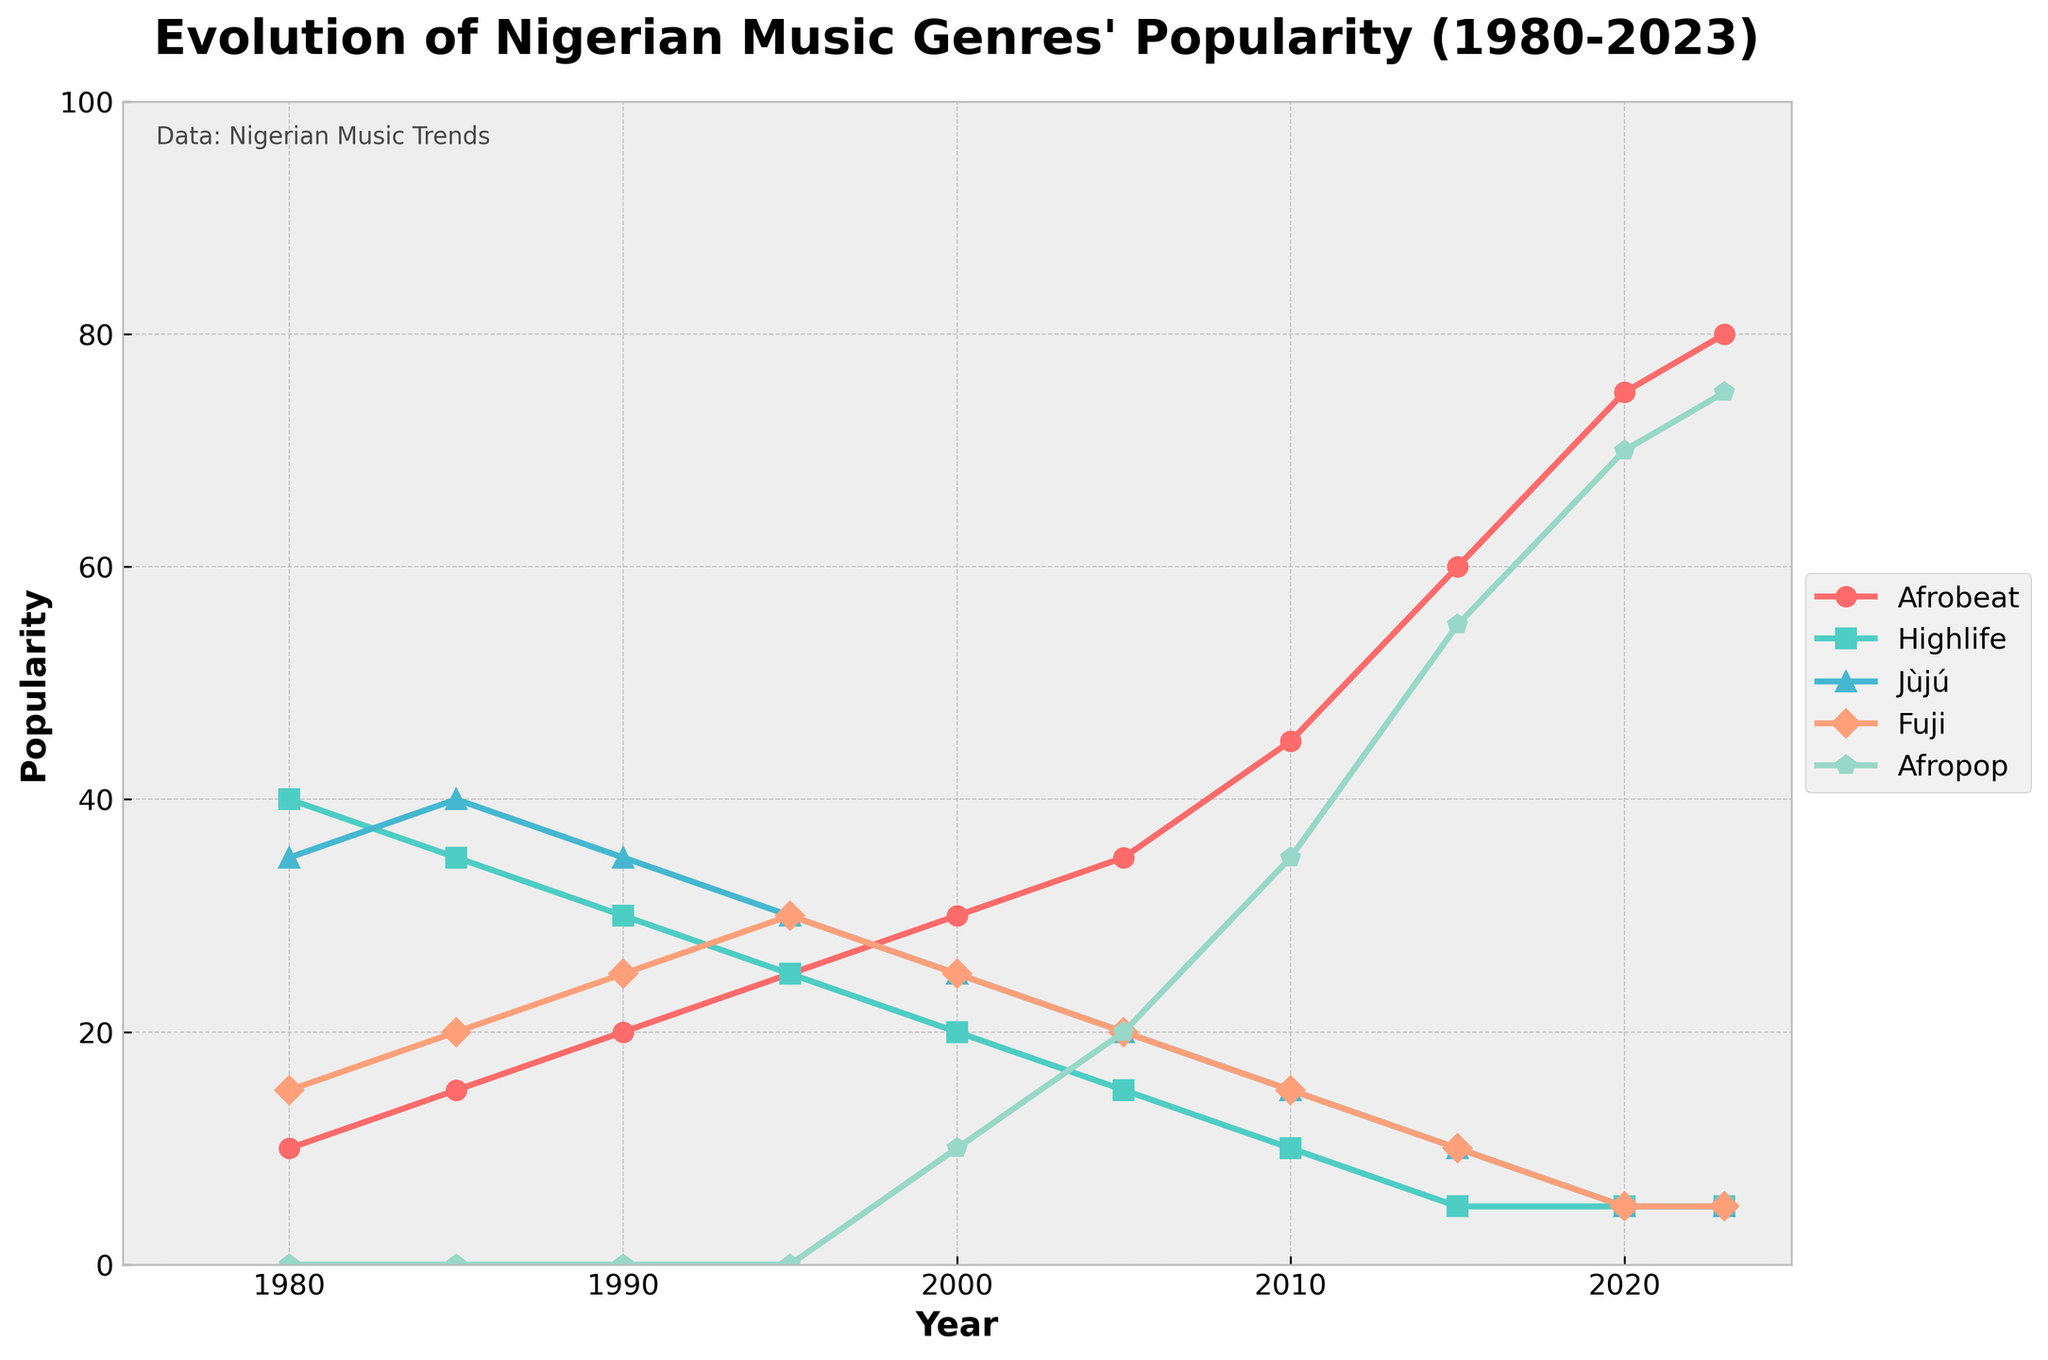What's the most popular genre in 1980? We look at the year 1980 on the x-axis and compare the heights of the lines. The highest line corresponds to Highlife with a value of 40.
Answer: Highlife How did Afrobeat's popularity change from 1980 to 2023? To determine the change, we compare the Afrobeat values in 1980 and 2023. Afrobeat was at 10 in 1980 and increased to 80 in 2023.
Answer: Increased Which genre had the most significant drop in popularity from 1980 to 2023? Compare the differences between 1980 and 2023 values for each genre. Highlife had a decline from 40 in 1980 to 5 in 2023, the most significant drop.
Answer: Highlife By how much did Afropop's popularity increase between 2000 and 2023? We subtract the 2000 value of Afropop from its 2023 value. 75 (2023) - 10 (2000) = 65.
Answer: 65 Which year did Afrobeat surpass Highlife in popularity? We need to check when the Afrobeat line rises above the Highlife line. This first happened in 1985 when Afrobeat was at 15 and Highlife was at 35.
Answer: 1985 How does the popularity of Jùjú in 1990 compare to its popularity in 2023? We compare the values of Jùjú in these two years. Both values are 35 in 1990 and 5 in 2023.
Answer: Decreased In which year did Afropop become more popular than Fuji? By comparing both genres annually, it is clear that Afropop surpassed Fuji in 2005.
Answer: 2005 What's the average popularity of Highlife from 1980 to 2023? Sum the Highlife values from 1980 to 2023, then divide by the number of years. (40 + 35 + 30 + 25 + 20 + 15 + 10 + 5 + 5 + 5) / 10 = 19.
Answer: 19 Which genre had a consistent decrease in popularity from 1980 to 2023? We look for a genre with decreasing values over time. Jùjú consistently decreased from 35 in 1980 to 5 in 2023.
Answer: Jùjú By how much did Fuji's popularity change between 1980 and 2023? We subtract the 1980 value of Fuji from its 2023 value. 5 (2023) - 15 (1980) = -10.
Answer: -10 